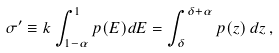Convert formula to latex. <formula><loc_0><loc_0><loc_500><loc_500>\sigma ^ { \prime } \equiv k \int _ { 1 - \alpha } ^ { 1 } p ( E ) d E = \int _ { \delta } ^ { \delta + \alpha } p ( z ) \, d z \, ,</formula> 